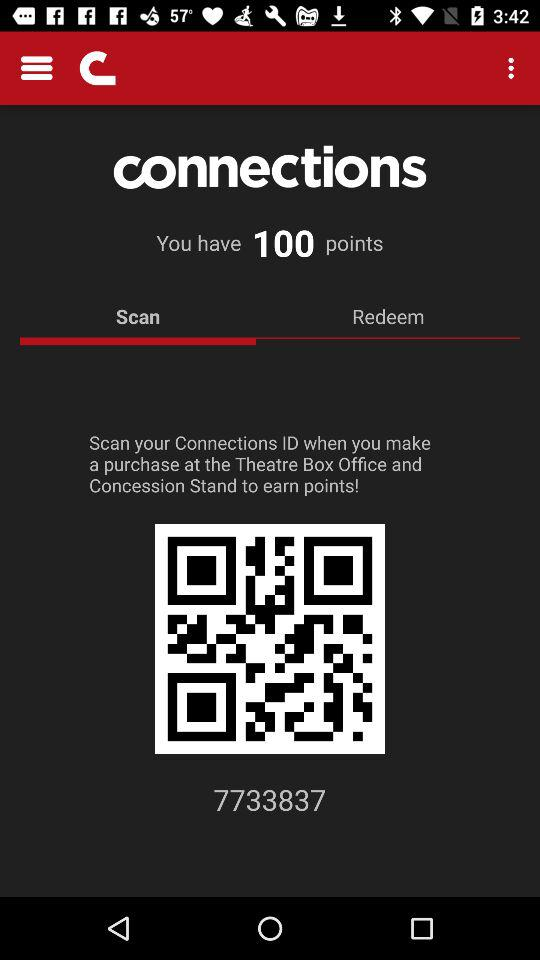What's the Connection Identity Number? The Connection Identity Number is 7733837. 